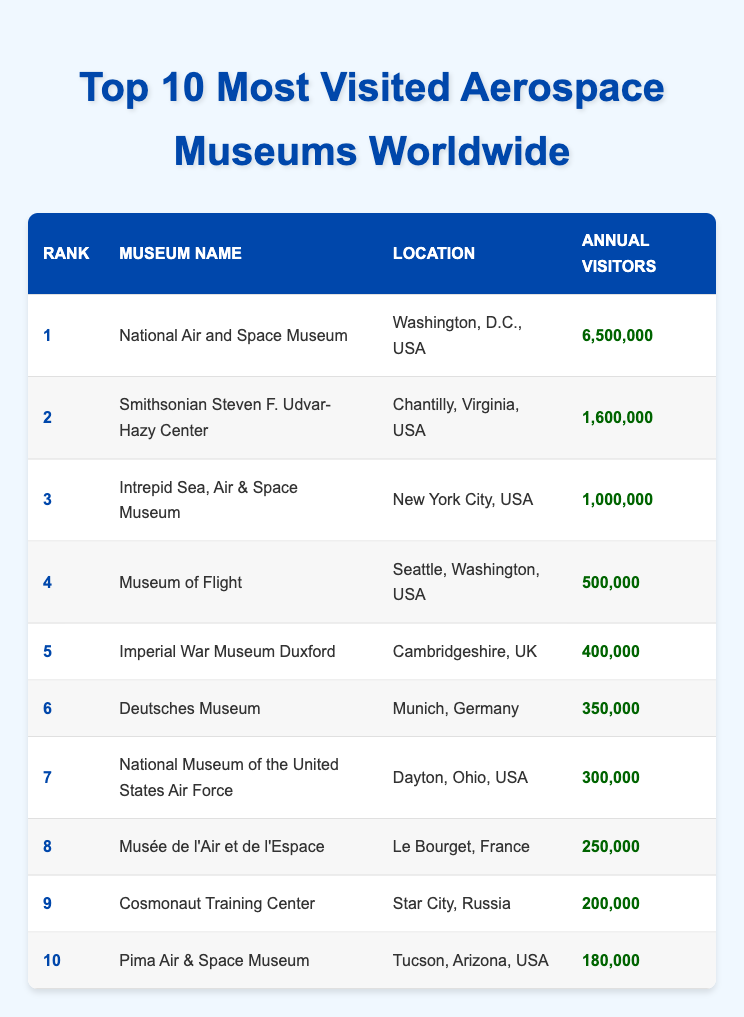What is the name of the most visited aerospace museum? The table lists the museums, and the one with the highest annual visitors is the National Air and Space Museum.
Answer: National Air and Space Museum How many annual visitors does the Imperial War Museum Duxford have? Looking at the table, the Imperial War Museum Duxford has listed annual visitors as 400,000.
Answer: 400,000 Which country is the Musée de l'Air et de l'Espace located in? The table specifies that the Musée de l'Air et de l'Espace is located in Le Bourget, France.
Answer: France What is the difference in annual visitors between the National Air and Space Museum and the Pima Air & Space Museum? The National Air and Space Museum has 6,500,000 visitors, and the Pima Air & Space Museum has 180,000 visitors. The difference is 6,500,000 - 180,000 = 6,320,000.
Answer: 6,320,000 Is the National Museum of the United States Air Force among the top 5 most visited aerospace museums? By checking the ranking in the table, the National Museum of the United States Air Force is ranked 7th, which is not within the top 5.
Answer: No What is the total number of annual visitors for the top 3 most visited aerospace museums? The top 3 museums are: National Air and Space Museum (6,500,000), Smithsonian Steven F. Udvar-Hazy Center (1,600,000), and Intrepid Sea, Air & Space Museum (1,000,000). Adding these gives: 6,500,000 + 1,600,000 + 1,000,000 = 9,100,000.
Answer: 9,100,000 How many of the top 10 museums are located in the USA? From the table, the following 7 museums are in the USA: National Air and Space Museum, Smithsonian Steven F. Udvar-Hazy Center, Intrepid Sea, Air & Space Museum, Museum of Flight, National Museum of the United States Air Force, and Pima Air & Space Museum.
Answer: 7 Which aerospace museum has the least number of annual visitors? The table reveals that the Pima Air & Space Museum has the least visitors, at 180,000.
Answer: Pima Air & Space Museum What is the average number of annual visitors for all the top 10 museums? Adding all visitors yields: 6,500,000 + 1,600,000 + 1,000,000 + 500,000 + 400,000 + 350,000 + 300,000 + 250,000 + 200,000 + 180,000 = 12,780,000; dividing by 10 gives an average of 1,278,000 visitors.
Answer: 1,278,000 